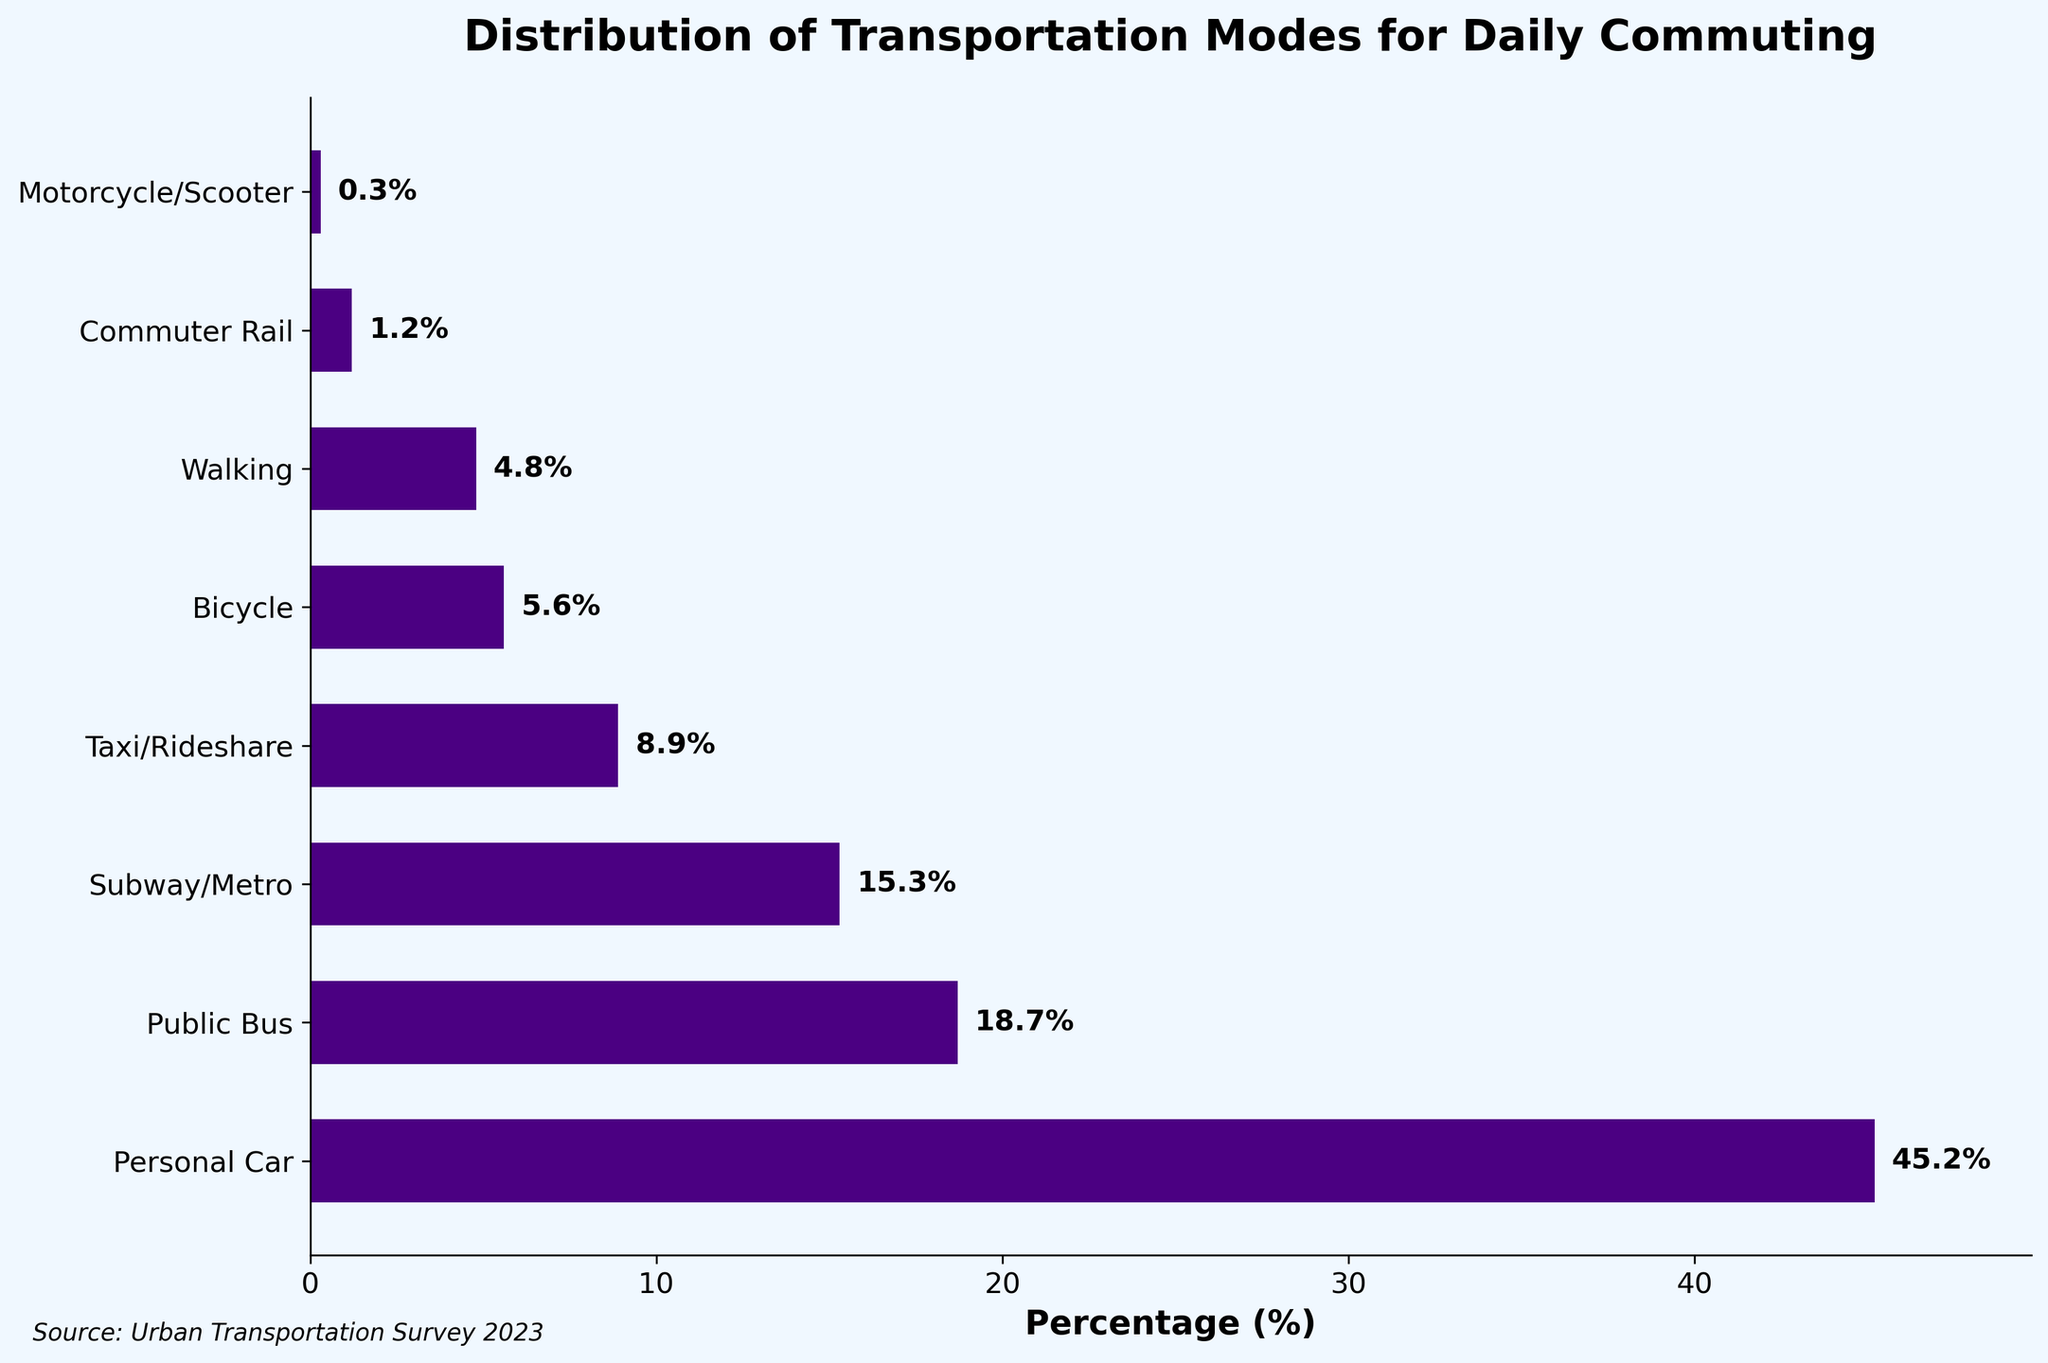Which transportation mode is used by the largest percentage of people for daily commuting? The largest percentage bar in the figure corresponds to the Personal Car category.
Answer: Personal Car How many percentage points more does the usage of Public Bus have compared to Subway/Metro? The Public Bus percentage is 18.7%, and Subway/Metro is 15.3%. The difference is 18.7% - 15.3% = 3.4%.
Answer: 3.4% What's the combined percentage of people using Taxi/Rideshare and Bicycle for their daily commute? Taxi/Rideshare accounts for 8.9% and Bicycle for 5.6%. The sum is 8.9% + 5.6% = 14.5%.
Answer: 14.5% Which mode of transportation has the smallest percentage, and what is that percentage? The smallest bar in the figure corresponds to the Motorcycle/Scooter category, which has a percentage of 0.3%.
Answer: Motorcycle/Scooter, 0.3% What is the difference in percentage between Walking and Bicycle? Walking is 4.8% while Bicycle is 5.6%. The difference is 5.6% - 4.8% = 0.8%.
Answer: 0.8% How does the percentage of people using Personal Car compare to the sum of those using Public Bus and Subway/Metro combined? Personal Car is 45.2%. Public Bus and Subway/Metro combined is 18.7% + 15.3% = 34.0%. Personal Car is greater by 45.2% - 34.0% = 11.2%.
Answer: Greater by 11.2% Which transportation modes have a percentage lower than 10%? The bars representing percentages lower than 10% are Taxi/Rideshare (8.9%), Bicycle (5.6%), Walking (4.8%), Commuter Rail (1.2%), and Motorcycle/Scooter (0.3%).
Answer: Taxi/Rideshare, Bicycle, Walking, Commuter Rail, Motorcycle/Scooter What percentage of people commute by walking compared to those using the Subway/Metro? Walking has a percentage of 4.8%, and Subway/Metro has 15.3%.
Answer: 4.8% vs 15.3% 